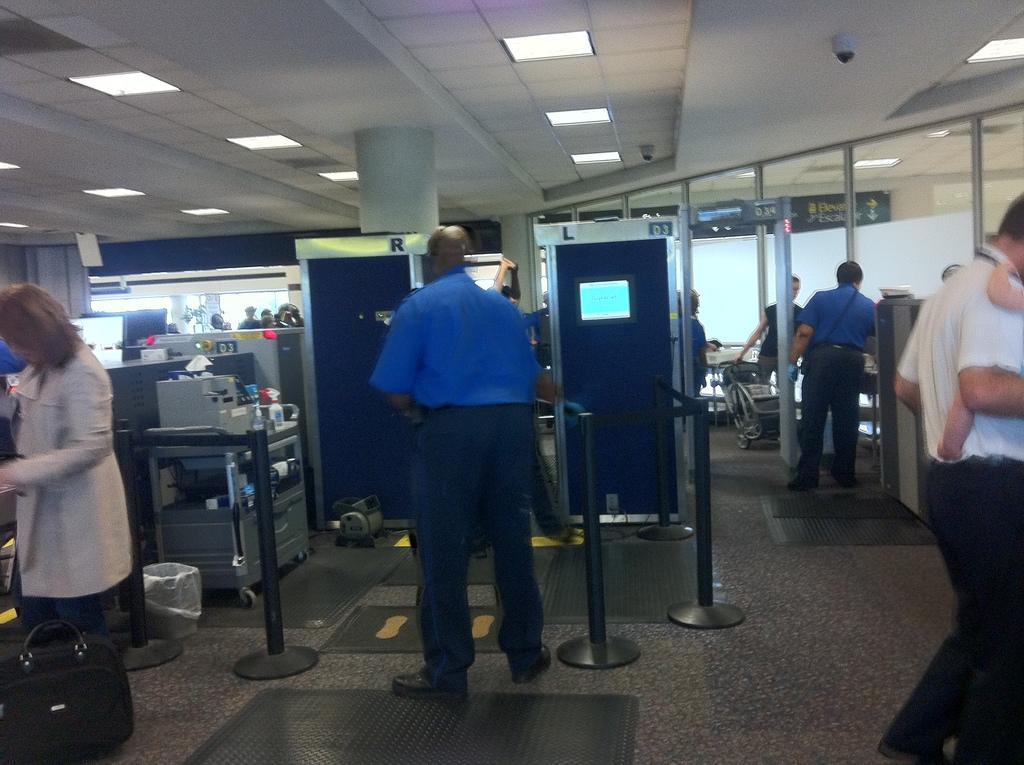In one or two sentences, can you explain what this image depicts? In this image we can see a few people standing, there are some machines, security check machines and some other objects, at the top of the roof we can see some lights. 